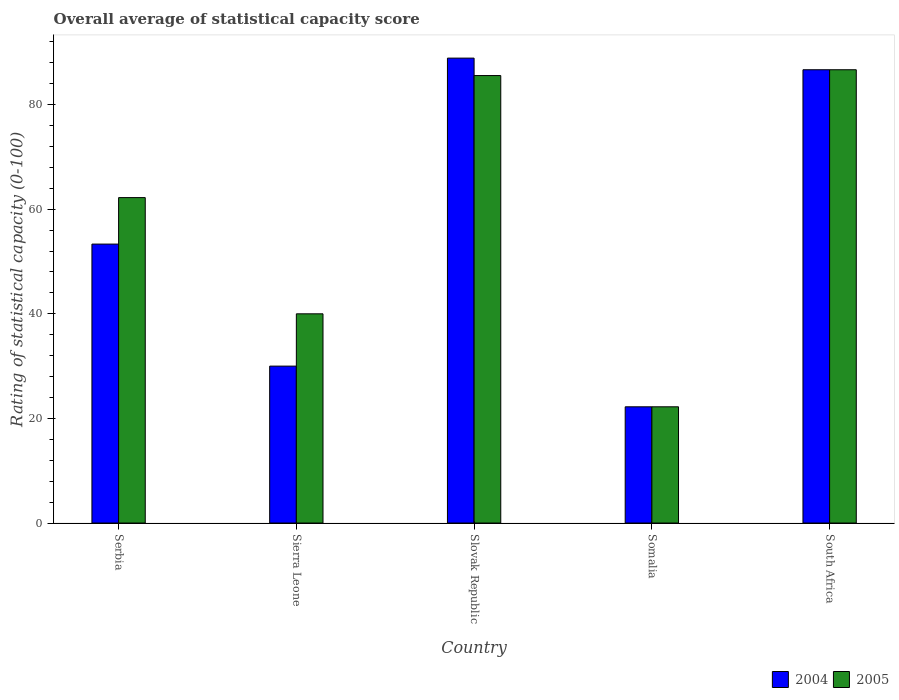How many different coloured bars are there?
Keep it short and to the point. 2. How many groups of bars are there?
Your response must be concise. 5. Are the number of bars per tick equal to the number of legend labels?
Your response must be concise. Yes. How many bars are there on the 5th tick from the right?
Offer a terse response. 2. What is the label of the 3rd group of bars from the left?
Your answer should be compact. Slovak Republic. Across all countries, what is the maximum rating of statistical capacity in 2005?
Offer a terse response. 86.67. Across all countries, what is the minimum rating of statistical capacity in 2005?
Provide a short and direct response. 22.22. In which country was the rating of statistical capacity in 2004 maximum?
Offer a very short reply. Slovak Republic. In which country was the rating of statistical capacity in 2004 minimum?
Your answer should be compact. Somalia. What is the total rating of statistical capacity in 2004 in the graph?
Offer a very short reply. 281.11. What is the difference between the rating of statistical capacity in 2004 in Sierra Leone and that in Slovak Republic?
Keep it short and to the point. -58.89. What is the difference between the rating of statistical capacity in 2005 in Sierra Leone and the rating of statistical capacity in 2004 in South Africa?
Make the answer very short. -46.67. What is the average rating of statistical capacity in 2005 per country?
Your response must be concise. 59.33. What is the difference between the rating of statistical capacity of/in 2004 and rating of statistical capacity of/in 2005 in Slovak Republic?
Your answer should be compact. 3.33. What is the ratio of the rating of statistical capacity in 2004 in Sierra Leone to that in Slovak Republic?
Ensure brevity in your answer.  0.34. Is the rating of statistical capacity in 2005 in Sierra Leone less than that in Slovak Republic?
Offer a terse response. Yes. Is the difference between the rating of statistical capacity in 2004 in Slovak Republic and Somalia greater than the difference between the rating of statistical capacity in 2005 in Slovak Republic and Somalia?
Provide a succinct answer. Yes. What is the difference between the highest and the second highest rating of statistical capacity in 2005?
Your answer should be compact. -23.34. What is the difference between the highest and the lowest rating of statistical capacity in 2005?
Ensure brevity in your answer.  64.44. In how many countries, is the rating of statistical capacity in 2004 greater than the average rating of statistical capacity in 2004 taken over all countries?
Keep it short and to the point. 2. What does the 1st bar from the right in Serbia represents?
Your answer should be compact. 2005. How many bars are there?
Offer a terse response. 10. Are the values on the major ticks of Y-axis written in scientific E-notation?
Ensure brevity in your answer.  No. Does the graph contain any zero values?
Your answer should be very brief. No. Does the graph contain grids?
Offer a very short reply. No. Where does the legend appear in the graph?
Keep it short and to the point. Bottom right. How many legend labels are there?
Your answer should be compact. 2. What is the title of the graph?
Your answer should be very brief. Overall average of statistical capacity score. What is the label or title of the X-axis?
Your answer should be compact. Country. What is the label or title of the Y-axis?
Offer a terse response. Rating of statistical capacity (0-100). What is the Rating of statistical capacity (0-100) in 2004 in Serbia?
Provide a succinct answer. 53.33. What is the Rating of statistical capacity (0-100) of 2005 in Serbia?
Your response must be concise. 62.22. What is the Rating of statistical capacity (0-100) in 2004 in Sierra Leone?
Your answer should be compact. 30. What is the Rating of statistical capacity (0-100) of 2005 in Sierra Leone?
Offer a terse response. 40. What is the Rating of statistical capacity (0-100) in 2004 in Slovak Republic?
Provide a succinct answer. 88.89. What is the Rating of statistical capacity (0-100) in 2005 in Slovak Republic?
Keep it short and to the point. 85.56. What is the Rating of statistical capacity (0-100) of 2004 in Somalia?
Ensure brevity in your answer.  22.22. What is the Rating of statistical capacity (0-100) of 2005 in Somalia?
Ensure brevity in your answer.  22.22. What is the Rating of statistical capacity (0-100) of 2004 in South Africa?
Keep it short and to the point. 86.67. What is the Rating of statistical capacity (0-100) in 2005 in South Africa?
Provide a succinct answer. 86.67. Across all countries, what is the maximum Rating of statistical capacity (0-100) in 2004?
Your answer should be very brief. 88.89. Across all countries, what is the maximum Rating of statistical capacity (0-100) in 2005?
Your response must be concise. 86.67. Across all countries, what is the minimum Rating of statistical capacity (0-100) in 2004?
Offer a terse response. 22.22. Across all countries, what is the minimum Rating of statistical capacity (0-100) of 2005?
Provide a succinct answer. 22.22. What is the total Rating of statistical capacity (0-100) in 2004 in the graph?
Your answer should be compact. 281.11. What is the total Rating of statistical capacity (0-100) of 2005 in the graph?
Provide a succinct answer. 296.66. What is the difference between the Rating of statistical capacity (0-100) in 2004 in Serbia and that in Sierra Leone?
Offer a terse response. 23.33. What is the difference between the Rating of statistical capacity (0-100) of 2005 in Serbia and that in Sierra Leone?
Make the answer very short. 22.22. What is the difference between the Rating of statistical capacity (0-100) in 2004 in Serbia and that in Slovak Republic?
Provide a short and direct response. -35.56. What is the difference between the Rating of statistical capacity (0-100) in 2005 in Serbia and that in Slovak Republic?
Give a very brief answer. -23.34. What is the difference between the Rating of statistical capacity (0-100) of 2004 in Serbia and that in Somalia?
Ensure brevity in your answer.  31.11. What is the difference between the Rating of statistical capacity (0-100) in 2005 in Serbia and that in Somalia?
Offer a very short reply. 40. What is the difference between the Rating of statistical capacity (0-100) of 2004 in Serbia and that in South Africa?
Provide a succinct answer. -33.33. What is the difference between the Rating of statistical capacity (0-100) of 2005 in Serbia and that in South Africa?
Provide a succinct answer. -24.45. What is the difference between the Rating of statistical capacity (0-100) of 2004 in Sierra Leone and that in Slovak Republic?
Provide a short and direct response. -58.89. What is the difference between the Rating of statistical capacity (0-100) in 2005 in Sierra Leone and that in Slovak Republic?
Offer a very short reply. -45.56. What is the difference between the Rating of statistical capacity (0-100) in 2004 in Sierra Leone and that in Somalia?
Provide a succinct answer. 7.78. What is the difference between the Rating of statistical capacity (0-100) in 2005 in Sierra Leone and that in Somalia?
Your response must be concise. 17.78. What is the difference between the Rating of statistical capacity (0-100) in 2004 in Sierra Leone and that in South Africa?
Keep it short and to the point. -56.67. What is the difference between the Rating of statistical capacity (0-100) of 2005 in Sierra Leone and that in South Africa?
Make the answer very short. -46.67. What is the difference between the Rating of statistical capacity (0-100) in 2004 in Slovak Republic and that in Somalia?
Your answer should be compact. 66.67. What is the difference between the Rating of statistical capacity (0-100) in 2005 in Slovak Republic and that in Somalia?
Your answer should be very brief. 63.33. What is the difference between the Rating of statistical capacity (0-100) of 2004 in Slovak Republic and that in South Africa?
Offer a terse response. 2.22. What is the difference between the Rating of statistical capacity (0-100) of 2005 in Slovak Republic and that in South Africa?
Keep it short and to the point. -1.11. What is the difference between the Rating of statistical capacity (0-100) in 2004 in Somalia and that in South Africa?
Make the answer very short. -64.44. What is the difference between the Rating of statistical capacity (0-100) of 2005 in Somalia and that in South Africa?
Offer a very short reply. -64.44. What is the difference between the Rating of statistical capacity (0-100) of 2004 in Serbia and the Rating of statistical capacity (0-100) of 2005 in Sierra Leone?
Give a very brief answer. 13.33. What is the difference between the Rating of statistical capacity (0-100) in 2004 in Serbia and the Rating of statistical capacity (0-100) in 2005 in Slovak Republic?
Your response must be concise. -32.22. What is the difference between the Rating of statistical capacity (0-100) of 2004 in Serbia and the Rating of statistical capacity (0-100) of 2005 in Somalia?
Ensure brevity in your answer.  31.11. What is the difference between the Rating of statistical capacity (0-100) of 2004 in Serbia and the Rating of statistical capacity (0-100) of 2005 in South Africa?
Offer a very short reply. -33.33. What is the difference between the Rating of statistical capacity (0-100) in 2004 in Sierra Leone and the Rating of statistical capacity (0-100) in 2005 in Slovak Republic?
Make the answer very short. -55.56. What is the difference between the Rating of statistical capacity (0-100) in 2004 in Sierra Leone and the Rating of statistical capacity (0-100) in 2005 in Somalia?
Make the answer very short. 7.78. What is the difference between the Rating of statistical capacity (0-100) in 2004 in Sierra Leone and the Rating of statistical capacity (0-100) in 2005 in South Africa?
Your answer should be very brief. -56.67. What is the difference between the Rating of statistical capacity (0-100) in 2004 in Slovak Republic and the Rating of statistical capacity (0-100) in 2005 in Somalia?
Your answer should be very brief. 66.67. What is the difference between the Rating of statistical capacity (0-100) in 2004 in Slovak Republic and the Rating of statistical capacity (0-100) in 2005 in South Africa?
Your answer should be compact. 2.22. What is the difference between the Rating of statistical capacity (0-100) of 2004 in Somalia and the Rating of statistical capacity (0-100) of 2005 in South Africa?
Your answer should be very brief. -64.44. What is the average Rating of statistical capacity (0-100) of 2004 per country?
Provide a succinct answer. 56.22. What is the average Rating of statistical capacity (0-100) in 2005 per country?
Offer a terse response. 59.33. What is the difference between the Rating of statistical capacity (0-100) of 2004 and Rating of statistical capacity (0-100) of 2005 in Serbia?
Provide a succinct answer. -8.89. What is the difference between the Rating of statistical capacity (0-100) in 2004 and Rating of statistical capacity (0-100) in 2005 in South Africa?
Keep it short and to the point. 0. What is the ratio of the Rating of statistical capacity (0-100) of 2004 in Serbia to that in Sierra Leone?
Keep it short and to the point. 1.78. What is the ratio of the Rating of statistical capacity (0-100) in 2005 in Serbia to that in Sierra Leone?
Make the answer very short. 1.56. What is the ratio of the Rating of statistical capacity (0-100) in 2005 in Serbia to that in Slovak Republic?
Ensure brevity in your answer.  0.73. What is the ratio of the Rating of statistical capacity (0-100) in 2004 in Serbia to that in Somalia?
Keep it short and to the point. 2.4. What is the ratio of the Rating of statistical capacity (0-100) in 2005 in Serbia to that in Somalia?
Your answer should be compact. 2.8. What is the ratio of the Rating of statistical capacity (0-100) in 2004 in Serbia to that in South Africa?
Offer a terse response. 0.62. What is the ratio of the Rating of statistical capacity (0-100) in 2005 in Serbia to that in South Africa?
Your answer should be compact. 0.72. What is the ratio of the Rating of statistical capacity (0-100) of 2004 in Sierra Leone to that in Slovak Republic?
Your answer should be compact. 0.34. What is the ratio of the Rating of statistical capacity (0-100) in 2005 in Sierra Leone to that in Slovak Republic?
Make the answer very short. 0.47. What is the ratio of the Rating of statistical capacity (0-100) in 2004 in Sierra Leone to that in Somalia?
Offer a very short reply. 1.35. What is the ratio of the Rating of statistical capacity (0-100) in 2005 in Sierra Leone to that in Somalia?
Make the answer very short. 1.8. What is the ratio of the Rating of statistical capacity (0-100) in 2004 in Sierra Leone to that in South Africa?
Your answer should be compact. 0.35. What is the ratio of the Rating of statistical capacity (0-100) of 2005 in Sierra Leone to that in South Africa?
Make the answer very short. 0.46. What is the ratio of the Rating of statistical capacity (0-100) of 2005 in Slovak Republic to that in Somalia?
Your answer should be compact. 3.85. What is the ratio of the Rating of statistical capacity (0-100) in 2004 in Slovak Republic to that in South Africa?
Your answer should be compact. 1.03. What is the ratio of the Rating of statistical capacity (0-100) in 2005 in Slovak Republic to that in South Africa?
Your response must be concise. 0.99. What is the ratio of the Rating of statistical capacity (0-100) in 2004 in Somalia to that in South Africa?
Give a very brief answer. 0.26. What is the ratio of the Rating of statistical capacity (0-100) of 2005 in Somalia to that in South Africa?
Offer a very short reply. 0.26. What is the difference between the highest and the second highest Rating of statistical capacity (0-100) of 2004?
Give a very brief answer. 2.22. What is the difference between the highest and the lowest Rating of statistical capacity (0-100) in 2004?
Your response must be concise. 66.67. What is the difference between the highest and the lowest Rating of statistical capacity (0-100) in 2005?
Provide a succinct answer. 64.44. 